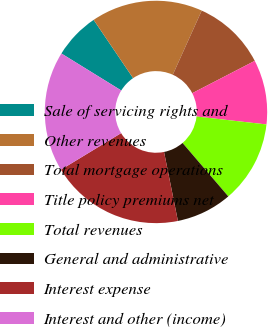Convert chart. <chart><loc_0><loc_0><loc_500><loc_500><pie_chart><fcel>Sale of servicing rights and<fcel>Other revenues<fcel>Total mortgage operations<fcel>Title policy premiums net<fcel>Total revenues<fcel>General and administrative<fcel>Interest expense<fcel>Interest and other (income)<nl><fcel>6.72%<fcel>16.22%<fcel>10.66%<fcel>9.39%<fcel>11.94%<fcel>8.11%<fcel>19.47%<fcel>17.5%<nl></chart> 